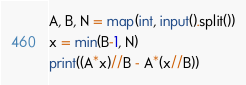Convert code to text. <code><loc_0><loc_0><loc_500><loc_500><_Python_>A, B, N = map(int, input().split())
x = min(B-1, N)
print((A*x)//B - A*(x//B))
</code> 